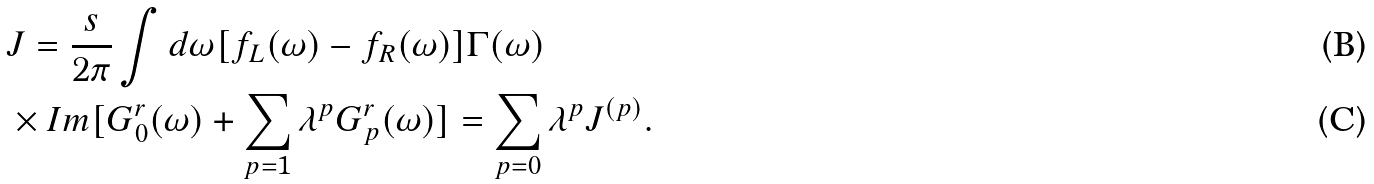Convert formula to latex. <formula><loc_0><loc_0><loc_500><loc_500>& J = \frac { s } { 2 \pi } \int d \omega [ f _ { L } ( \omega ) - f _ { R } ( \omega ) ] \Gamma ( \omega ) \\ & \times I m [ G ^ { r } _ { 0 } ( \omega ) + \sum _ { p = 1 } \lambda ^ { p } G ^ { r } _ { p } ( \omega ) ] = \sum _ { p = 0 } \lambda ^ { p } J ^ { ( p ) } .</formula> 